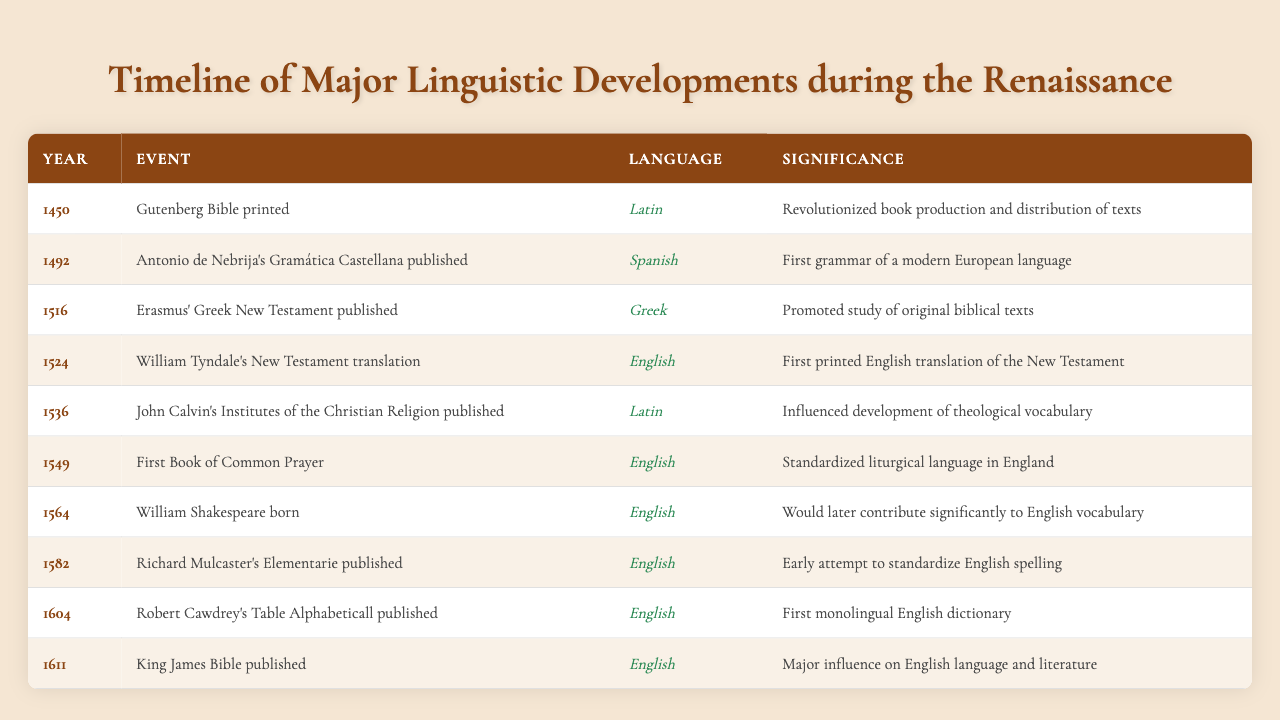What year was the Gutenberg Bible printed? The table lists the event and year for the Gutenberg Bible as 1450.
Answer: 1450 Which language had the first grammar published in the Renaissance? According to the table, the first grammar published during the Renaissance was Antonio de Nebrija's Gramática Castellana in Spanish in 1492.
Answer: Spanish How many significant events in English language development occurred from 1524 to 1611? Examining the table, four significant events related to the English language occurred in this period: Tyndale's New Testament translation (1524), the First Book of Common Prayer (1549), the birth of Shakespeare (1564), and the King James Bible (1611).
Answer: Four Was Richard Mulcaster's Elementarie published before or after the King James Bible? The table shows that Richard Mulcaster's Elementarie was published in 1582, which is before the King James Bible published in 1611.
Answer: Before What is the significance of Erasmus' Greek New Testament published in 1516? The table indicates that Erasmus' Greek New Testament promoted the study of original biblical texts, highlighting its importance in Renaissance linguistic developments.
Answer: Promoted study of biblical texts Identify the year with the first printed English translation of the New Testament and its significance. The table specifies that William Tyndale's New Testament translation occurred in 1524, marking it as the first printed English translation of the New Testament.
Answer: 1524 and first printed translation Count the number of events that significantly contributed to standardizing English spelling and language. By reviewing the events, Richard Mulcaster's Elementarie (1582) and the First Book of Common Prayer (1549) contributed to the standardization of English spelling and language, totaling two events.
Answer: Two In which year did William Shakespeare, a key figure in English vocabulary development, was born? The table mentions that William Shakespeare was born in 1564, making it the year he joined the timeline of notable linguistic developments.
Answer: 1564 Were there any publications in Greek during the Renaissance period according to the table? Yes, the table lists Erasmus' Greek New Testament published in 1516, confirming a publication in Greek during the Renaissance.
Answer: Yes What was the significance of the King James Bible published in 1611 regarding the English language? The table states that the King James Bible had a major influence on the English language and literature, emphasizing its significance during the period.
Answer: Major influence on language and literature What event marked the first attempt to standardize English spelling? According to the table, Richard Mulcaster's Elementarie published in 1582 marks an early attempt to standardize English spelling.
Answer: Richard Mulcaster's Elementarie 